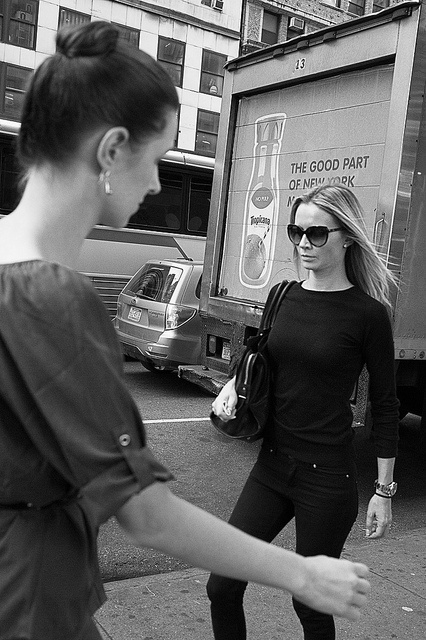Describe the objects in this image and their specific colors. I can see people in black, gray, darkgray, and lightgray tones, truck in black, darkgray, gray, and lightgray tones, people in black, gray, darkgray, and lightgray tones, bus in black, darkgray, gray, and lightgray tones, and car in black, gray, darkgray, and lightgray tones in this image. 